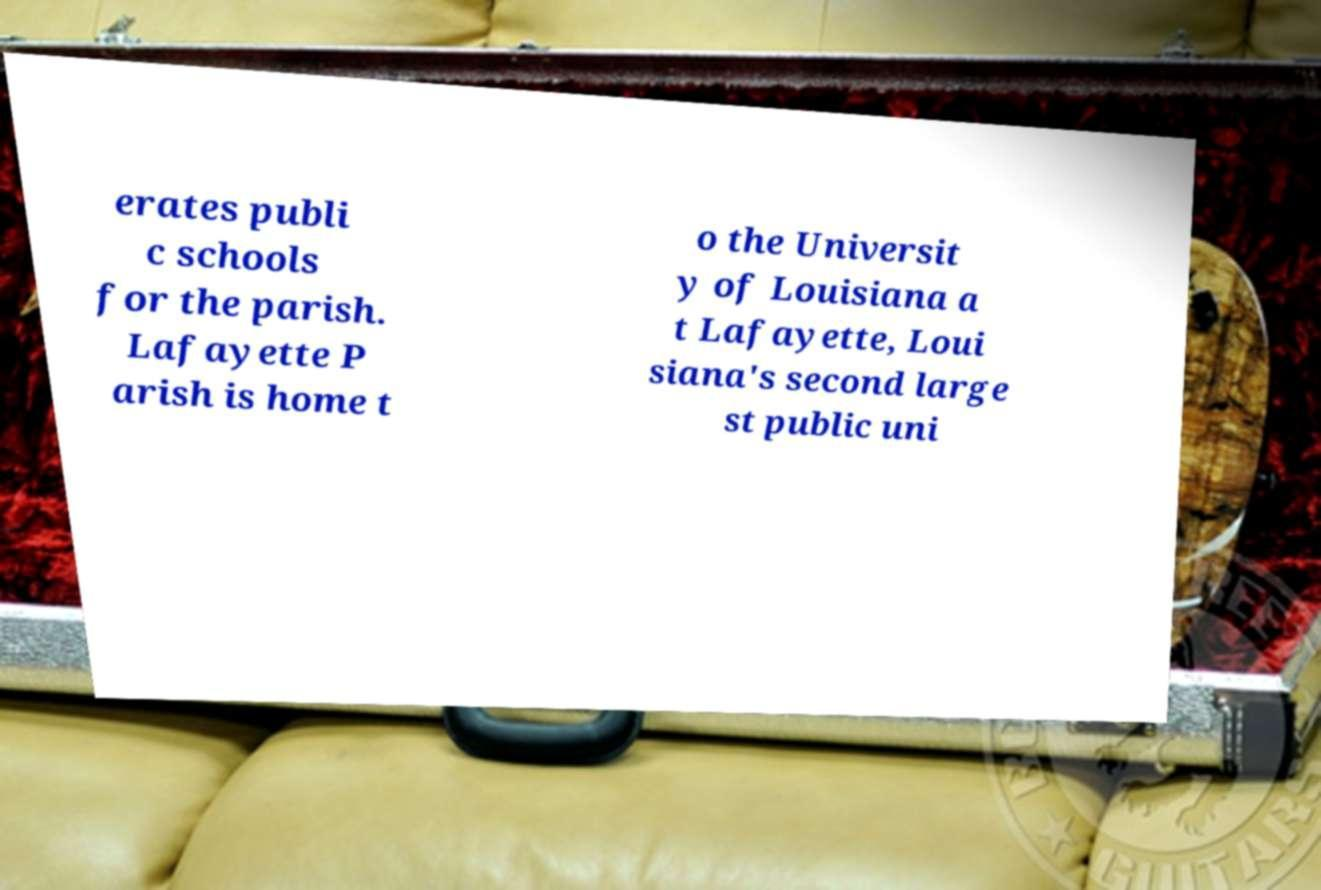Please identify and transcribe the text found in this image. erates publi c schools for the parish. Lafayette P arish is home t o the Universit y of Louisiana a t Lafayette, Loui siana's second large st public uni 